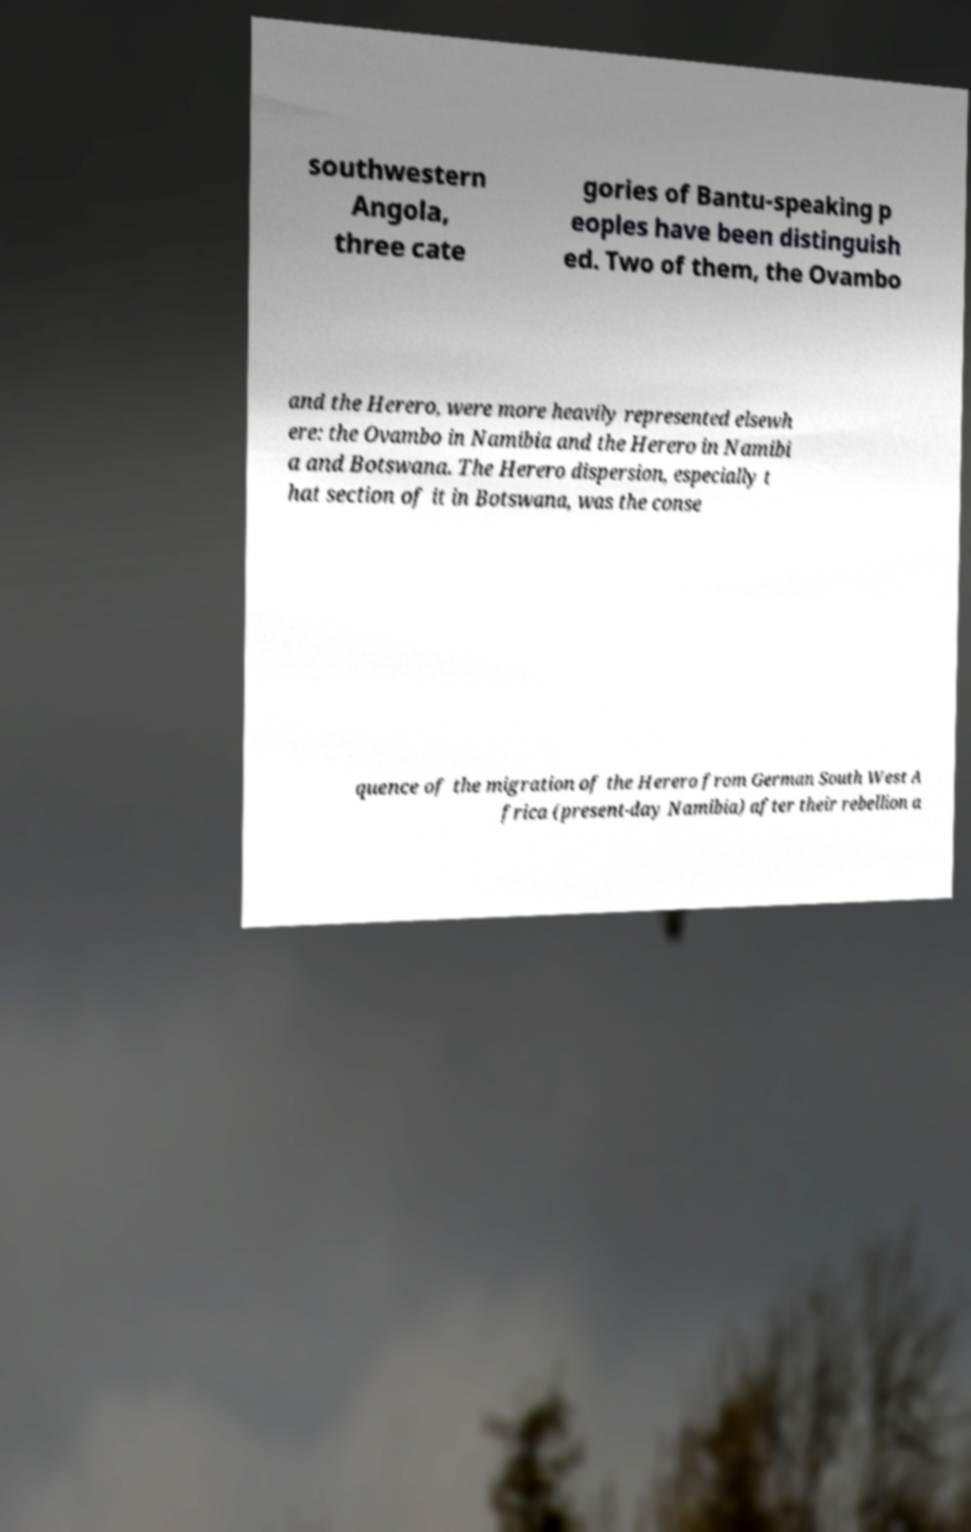I need the written content from this picture converted into text. Can you do that? southwestern Angola, three cate gories of Bantu-speaking p eoples have been distinguish ed. Two of them, the Ovambo and the Herero, were more heavily represented elsewh ere: the Ovambo in Namibia and the Herero in Namibi a and Botswana. The Herero dispersion, especially t hat section of it in Botswana, was the conse quence of the migration of the Herero from German South West A frica (present-day Namibia) after their rebellion a 